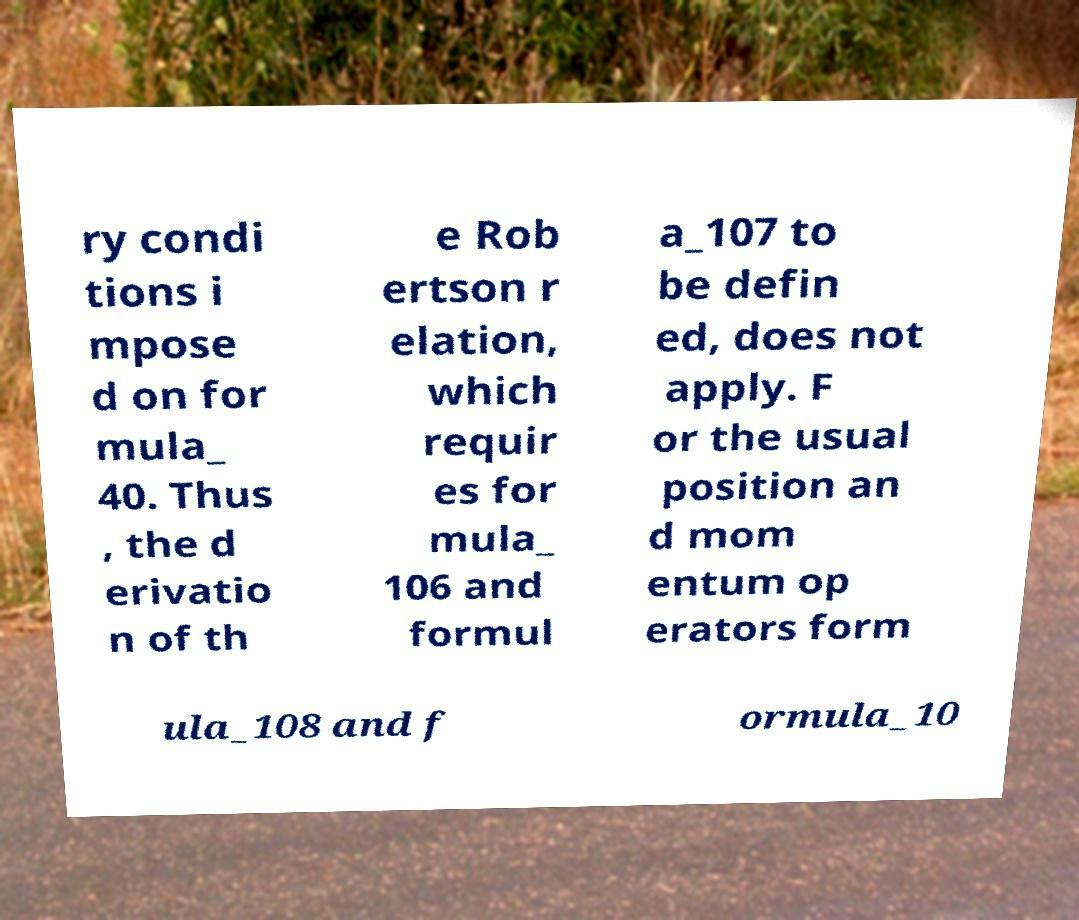Please identify and transcribe the text found in this image. ry condi tions i mpose d on for mula_ 40. Thus , the d erivatio n of th e Rob ertson r elation, which requir es for mula_ 106 and formul a_107 to be defin ed, does not apply. F or the usual position an d mom entum op erators form ula_108 and f ormula_10 